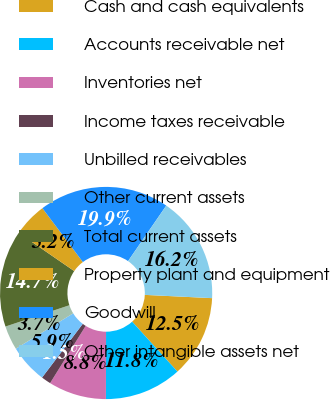Convert chart to OTSL. <chart><loc_0><loc_0><loc_500><loc_500><pie_chart><fcel>Cash and cash equivalents<fcel>Accounts receivable net<fcel>Inventories net<fcel>Income taxes receivable<fcel>Unbilled receivables<fcel>Other current assets<fcel>Total current assets<fcel>Property plant and equipment<fcel>Goodwill<fcel>Other intangible assets net<nl><fcel>12.5%<fcel>11.76%<fcel>8.82%<fcel>1.47%<fcel>5.88%<fcel>3.68%<fcel>14.71%<fcel>5.15%<fcel>19.85%<fcel>16.18%<nl></chart> 